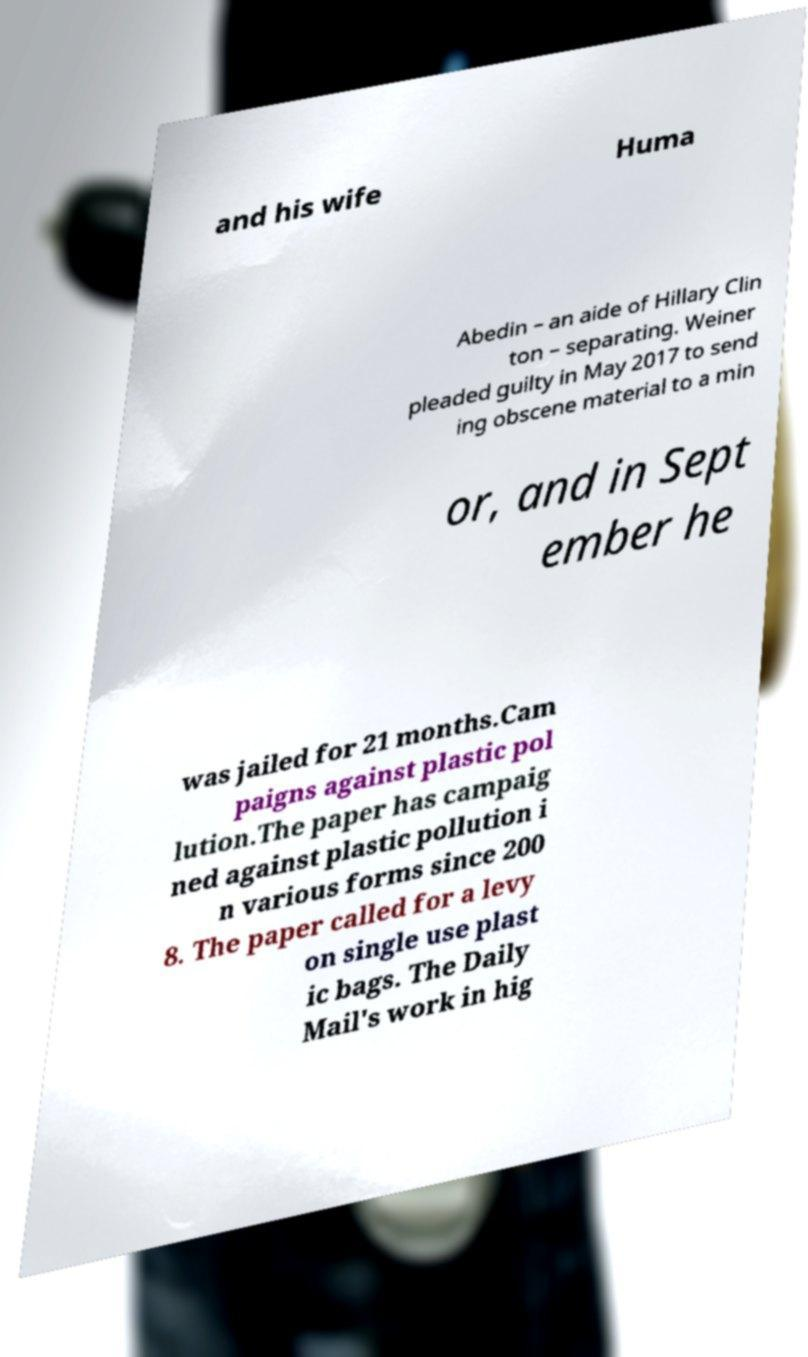There's text embedded in this image that I need extracted. Can you transcribe it verbatim? and his wife Huma Abedin – an aide of Hillary Clin ton – separating. Weiner pleaded guilty in May 2017 to send ing obscene material to a min or, and in Sept ember he was jailed for 21 months.Cam paigns against plastic pol lution.The paper has campaig ned against plastic pollution i n various forms since 200 8. The paper called for a levy on single use plast ic bags. The Daily Mail's work in hig 